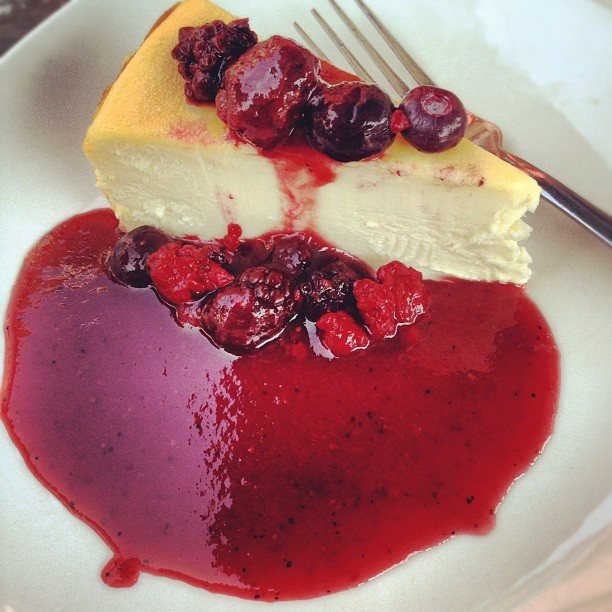Describe the objects in this image and their specific colors. I can see cake in gray, beige, tan, and maroon tones and fork in gray, tan, brown, and darkgray tones in this image. 